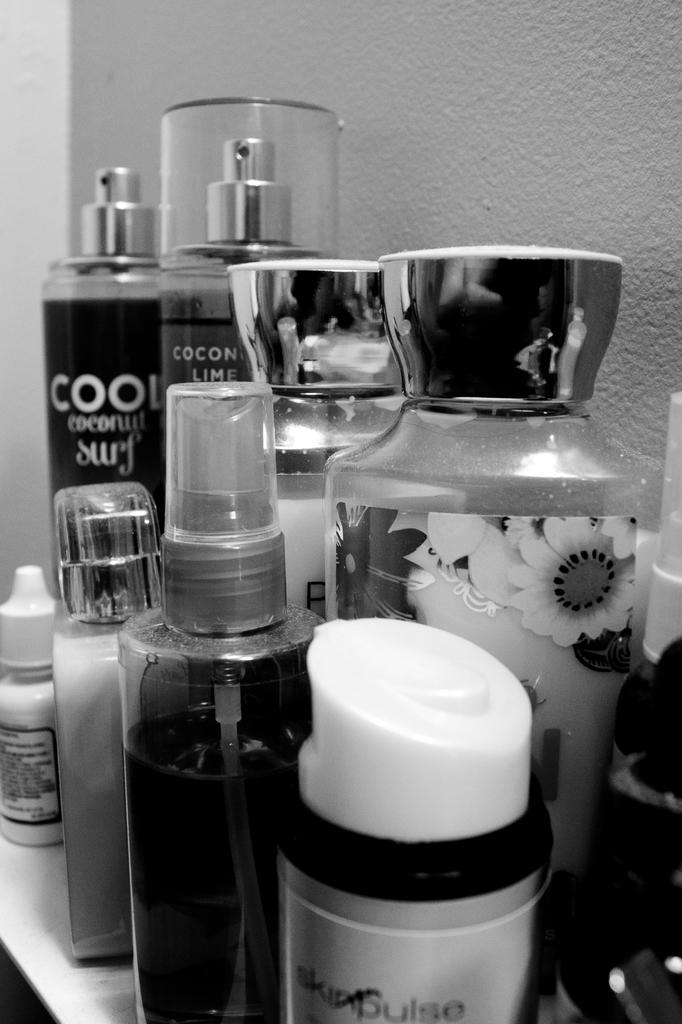What type of products are shown in the image? There are many perfumes in the image. Can you describe the bottles containing the perfumes? The perfumes are in different sizes of bottles. Is there a stove visible in the image? No, there is no stove present in the image. 